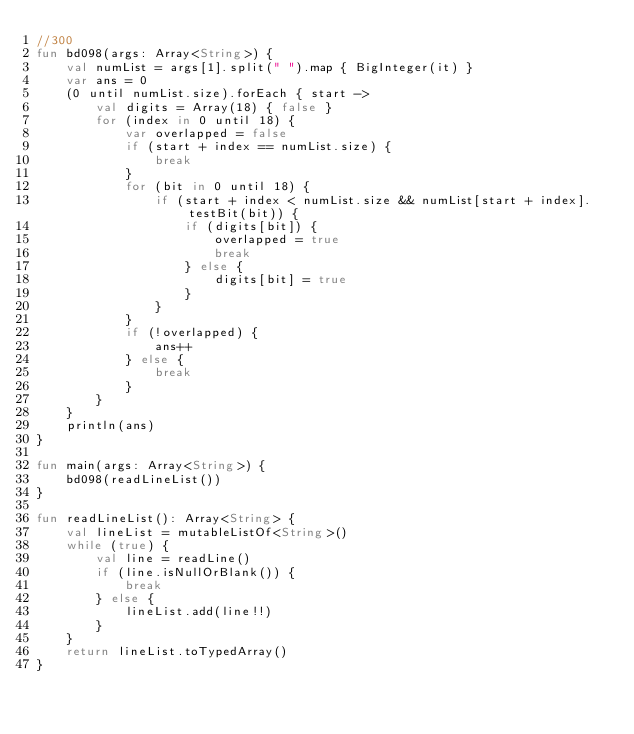<code> <loc_0><loc_0><loc_500><loc_500><_Kotlin_>//300
fun bd098(args: Array<String>) {
    val numList = args[1].split(" ").map { BigInteger(it) }
    var ans = 0
    (0 until numList.size).forEach { start ->
        val digits = Array(18) { false }
        for (index in 0 until 18) {
            var overlapped = false
            if (start + index == numList.size) {
                break
            }
            for (bit in 0 until 18) {
                if (start + index < numList.size && numList[start + index].testBit(bit)) {
                    if (digits[bit]) {
                        overlapped = true
                        break
                    } else {
                        digits[bit] = true
                    }
                }
            }
            if (!overlapped) {
                ans++
            } else {
                break
            }
        }
    }
    println(ans)
}

fun main(args: Array<String>) {
    bd098(readLineList())
}

fun readLineList(): Array<String> {
    val lineList = mutableListOf<String>()
    while (true) {
        val line = readLine()
        if (line.isNullOrBlank()) {
            break
        } else {
            lineList.add(line!!)
        }
    }
    return lineList.toTypedArray()
}</code> 